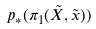<formula> <loc_0><loc_0><loc_500><loc_500>p _ { * } ( \pi _ { 1 } ( \tilde { X } , \tilde { x } ) )</formula> 